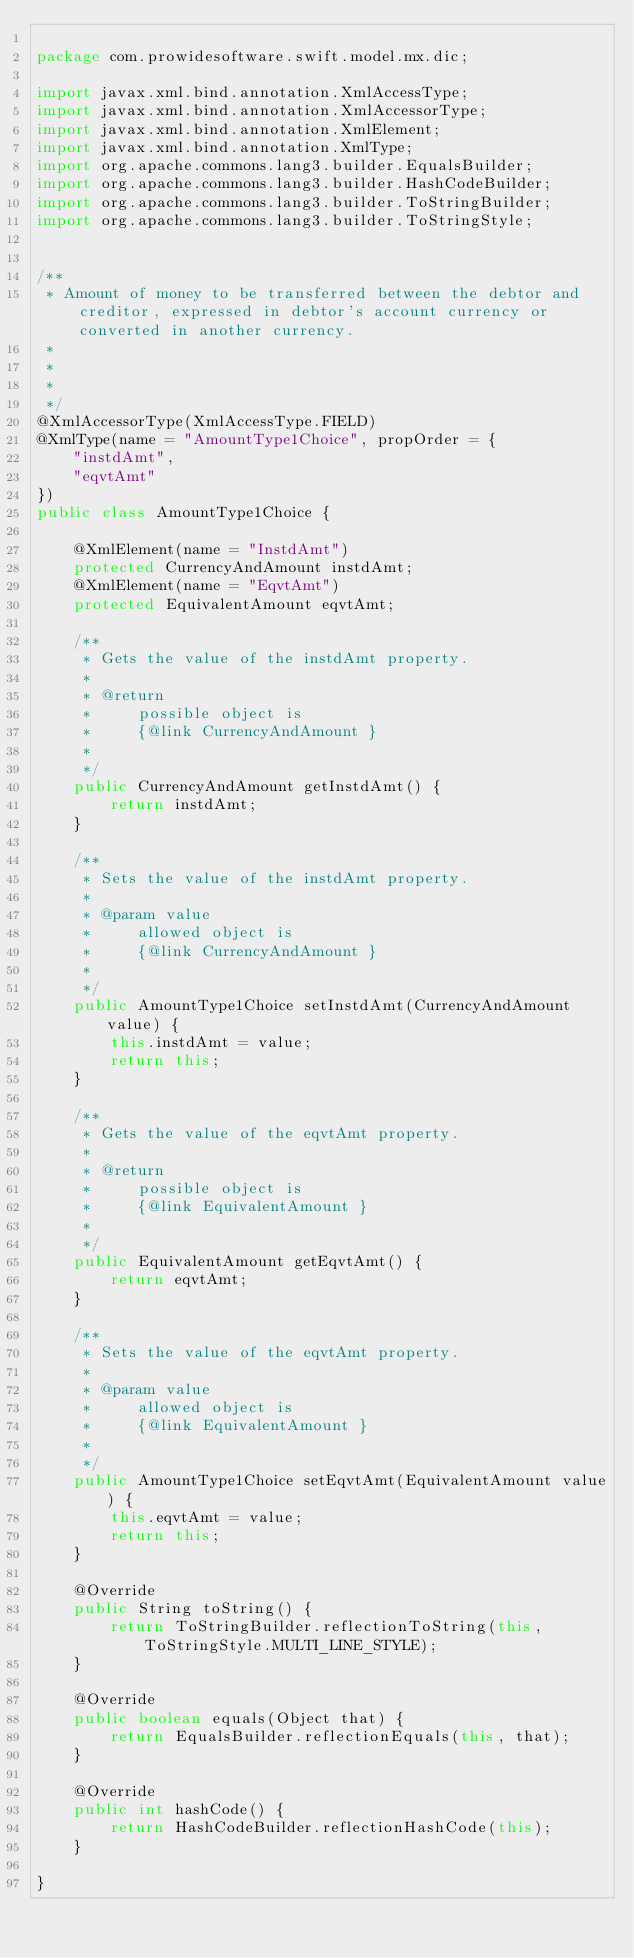<code> <loc_0><loc_0><loc_500><loc_500><_Java_>
package com.prowidesoftware.swift.model.mx.dic;

import javax.xml.bind.annotation.XmlAccessType;
import javax.xml.bind.annotation.XmlAccessorType;
import javax.xml.bind.annotation.XmlElement;
import javax.xml.bind.annotation.XmlType;
import org.apache.commons.lang3.builder.EqualsBuilder;
import org.apache.commons.lang3.builder.HashCodeBuilder;
import org.apache.commons.lang3.builder.ToStringBuilder;
import org.apache.commons.lang3.builder.ToStringStyle;


/**
 * Amount of money to be transferred between the debtor and creditor, expressed in debtor's account currency or converted in another currency.
 * 
 * 
 * 
 */
@XmlAccessorType(XmlAccessType.FIELD)
@XmlType(name = "AmountType1Choice", propOrder = {
    "instdAmt",
    "eqvtAmt"
})
public class AmountType1Choice {

    @XmlElement(name = "InstdAmt")
    protected CurrencyAndAmount instdAmt;
    @XmlElement(name = "EqvtAmt")
    protected EquivalentAmount eqvtAmt;

    /**
     * Gets the value of the instdAmt property.
     * 
     * @return
     *     possible object is
     *     {@link CurrencyAndAmount }
     *     
     */
    public CurrencyAndAmount getInstdAmt() {
        return instdAmt;
    }

    /**
     * Sets the value of the instdAmt property.
     * 
     * @param value
     *     allowed object is
     *     {@link CurrencyAndAmount }
     *     
     */
    public AmountType1Choice setInstdAmt(CurrencyAndAmount value) {
        this.instdAmt = value;
        return this;
    }

    /**
     * Gets the value of the eqvtAmt property.
     * 
     * @return
     *     possible object is
     *     {@link EquivalentAmount }
     *     
     */
    public EquivalentAmount getEqvtAmt() {
        return eqvtAmt;
    }

    /**
     * Sets the value of the eqvtAmt property.
     * 
     * @param value
     *     allowed object is
     *     {@link EquivalentAmount }
     *     
     */
    public AmountType1Choice setEqvtAmt(EquivalentAmount value) {
        this.eqvtAmt = value;
        return this;
    }

    @Override
    public String toString() {
        return ToStringBuilder.reflectionToString(this, ToStringStyle.MULTI_LINE_STYLE);
    }

    @Override
    public boolean equals(Object that) {
        return EqualsBuilder.reflectionEquals(this, that);
    }

    @Override
    public int hashCode() {
        return HashCodeBuilder.reflectionHashCode(this);
    }

}
</code> 